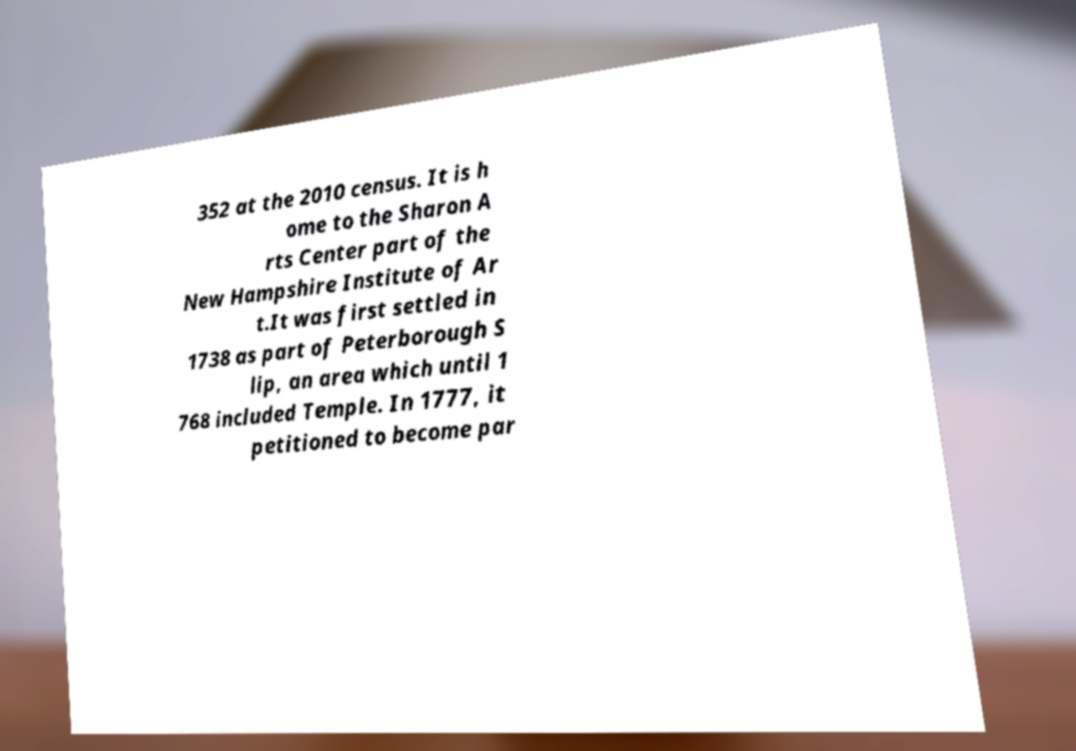Please read and relay the text visible in this image. What does it say? 352 at the 2010 census. It is h ome to the Sharon A rts Center part of the New Hampshire Institute of Ar t.It was first settled in 1738 as part of Peterborough S lip, an area which until 1 768 included Temple. In 1777, it petitioned to become par 